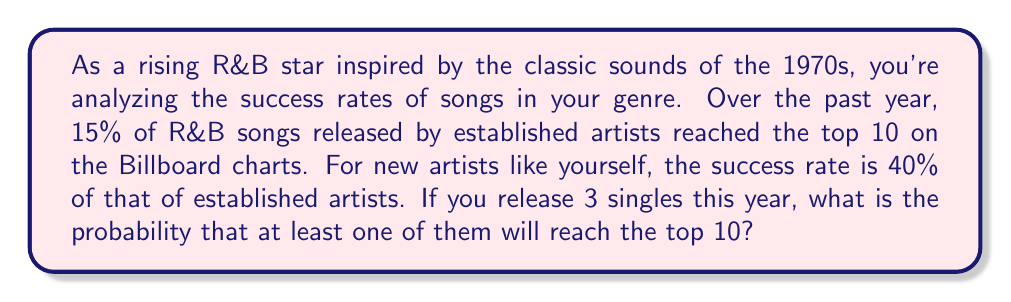Teach me how to tackle this problem. Let's approach this step-by-step:

1) First, let's calculate the probability of success for a new artist:
   $P(\text{success for new artist}) = 0.15 \times 0.40 = 0.06$ or 6%

2) Now, we need to find the probability of at least one song reaching the top 10 out of 3 singles. It's easier to calculate the probability of no songs reaching the top 10 and then subtract that from 1.

3) The probability of a single not reaching the top 10 is:
   $P(\text{failure}) = 1 - 0.06 = 0.94$

4) For all 3 singles to not reach the top 10, each must independently fail:
   $P(\text{all 3 fail}) = 0.94 \times 0.94 \times 0.94 = 0.94^3$

5) We can calculate this:
   $0.94^3 \approx 0.830584$

6) Therefore, the probability of at least one song reaching the top 10 is:
   $P(\text{at least one success}) = 1 - P(\text{all 3 fail})$
   $= 1 - 0.830584 = 0.169416$

7) Converting to a percentage:
   $0.169416 \times 100\% \approx 16.94\%$
Answer: The probability that at least one of your three singles will reach the top 10 on the Billboard charts is approximately 16.94% or 0.1694. 